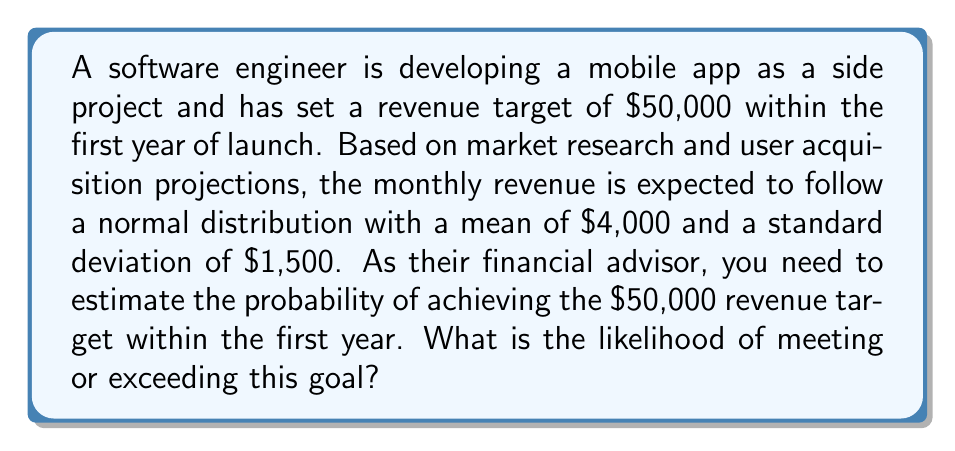Help me with this question. To solve this problem, we need to follow these steps:

1. Calculate the total expected revenue for the year:
   $\mu_{year} = 12 \times \$4,000 = \$48,000$

2. Calculate the standard deviation for the year:
   $\sigma_{year} = \sqrt{12} \times \$1,500 = \$5,196.15$

3. Calculate the z-score for the target revenue:
   $$z = \frac{X - \mu}{\sigma} = \frac{\$50,000 - \$48,000}{\$5,196.15} = 0.3848$$

4. Use the standard normal distribution table or a calculator to find the probability of exceeding this z-score.

The probability of exceeding a z-score of 0.3848 is:
$P(Z > 0.3848) = 1 - P(Z < 0.3848) = 1 - 0.6498 = 0.3502$

Therefore, the probability of meeting or exceeding the $50,000 revenue target within the first year is approximately 0.3502 or 35.02%.
Answer: The likelihood of meeting or exceeding the $50,000 revenue target within the first year is approximately 35.02%. 